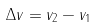<formula> <loc_0><loc_0><loc_500><loc_500>\Delta v = v _ { 2 } - v _ { 1 }</formula> 